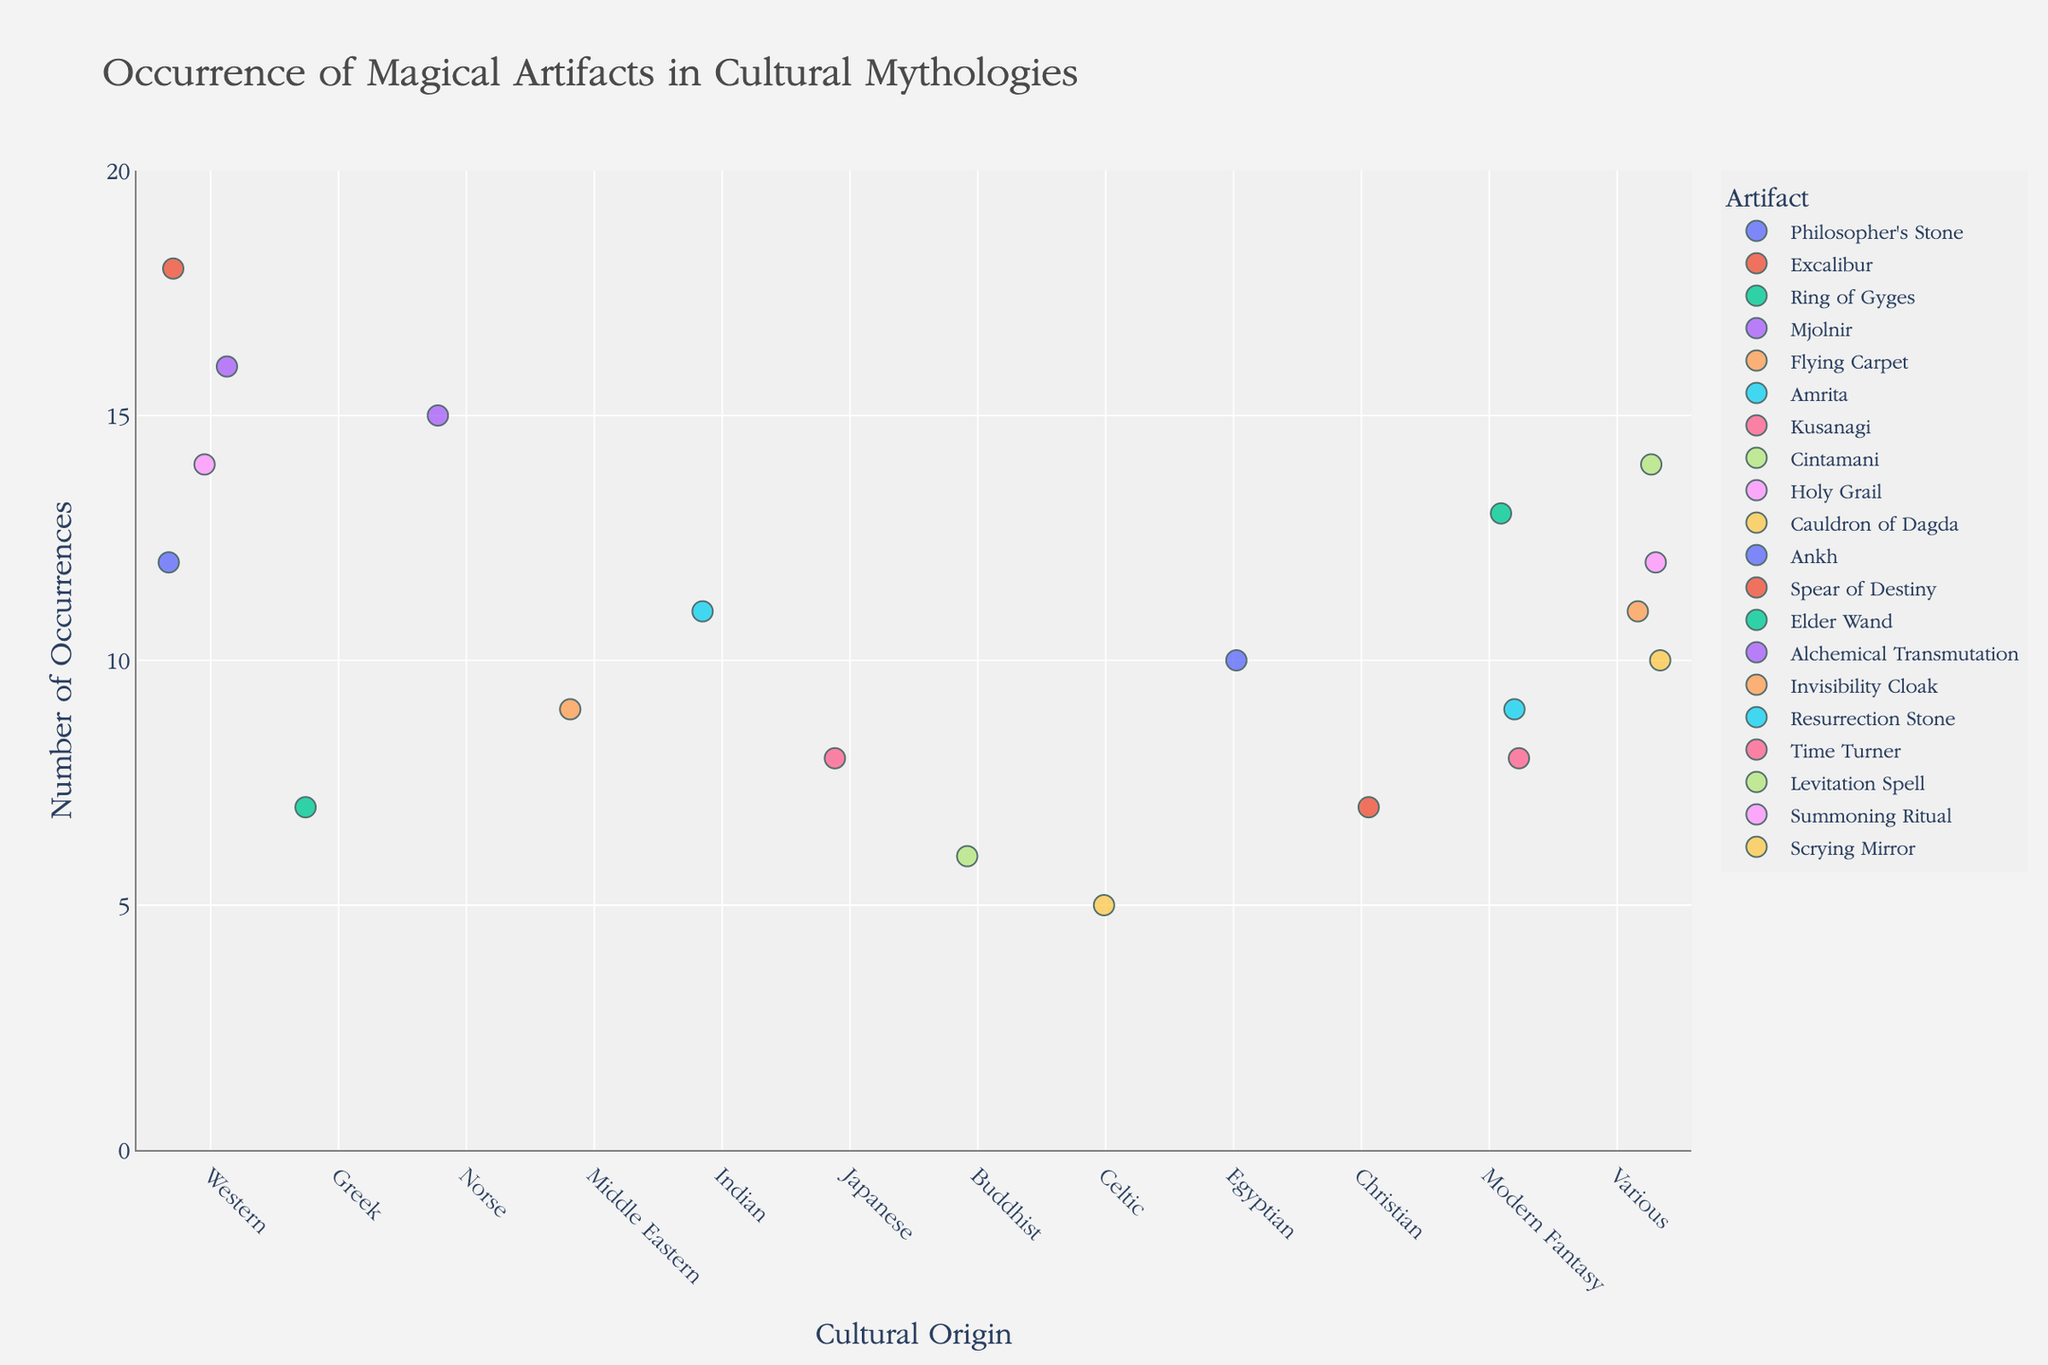What's the title of the plot? The title is usually located at the top of the plot and acts as a summary of what the data visualizes. Here, it is clearly stated as "Occurrence of Magical Artifacts in Cultural Mythologies".
Answer: Occurrence of Magical Artifacts in Cultural Mythologies What is the range of the Occurrences axis? By looking at the y-axis labels, you can see it starts from 0 and goes up to a maximum value just above the highest data point, which here seems to be 18, and the range is further extended by 2 units as stated.
Answer: 0 to 20 Which magical artifact has the highest number of occurrences? By looking at the strip plot and identifying the highest data point on the y-axis, you can see that "Excalibur" in Western culture has the highest number with 18 occurrences.
Answer: Excalibur Which cultures contain artifacts with occurrences of exactly 10? Examine the strip plot and look for data points aligned with the y-axis mark of 10. The artifacts "Ankh" and "Scrying Mirror" both correspond to this number. The cultures for these artifacts are "Egyptian" for Ankh and "Various" for the Scrying Mirror.
Answer: Egyptian, Various How many artifacts are listed under Western culture? On the x-axis under the "Western" category, we see multiple data points. Counting them gives us the artifacts: Philosopher's Stone, Excalibur, Holy Grail, Alchemical Transmutation, indicating a total of 4 artifacts.
Answer: 4 Which artifact in Modern Fantasy culture has the highest occurrence? By looking at the plot under the "Modern Fantasy" culture on the x-axis, the highest data point corresponds to the "Elder Wand" with 13 occurrences.
Answer: Elder Wand How many different artifacts have exactly 7 occurrences? By examining the plot and counting the artifacts represented at the 7 occurrences mark on the y-axis, we find two: "Ring of Gyges" and "Spear of Destiny".
Answer: 2 Compare the number of occurrences of the Philosopher’s Stone and the Flying Carpet. Which has more and by how much? By locating the Philosopher’s Stone under Western and Flying Carpet under Middle Eastern on the x-axis, we see 12 vs. 9 occurrences respectively. Subtract 9 from 12 to find the difference.
Answer: Philosopher’s Stone has more; by 3 occurrences What is the average number of occurrences among artifacts in the "Various" category? Identify the occurrences of artifacts under the "Various" category: Invisibility Cloak (11), Levitation Spell (14), Summoning Ritual (12), Scrying Mirror (10). Sum these values (11+14+12+10)=47 and divide by the number of artifacts (4).
Answer: 11.75 Which artifact in the Japanese culture has been noted, and how many times? By looking under "Japanese" culture on the x-axis, we find "Kusanagi" with 8 occurrences.
Answer: Kusanagi; 8 times 